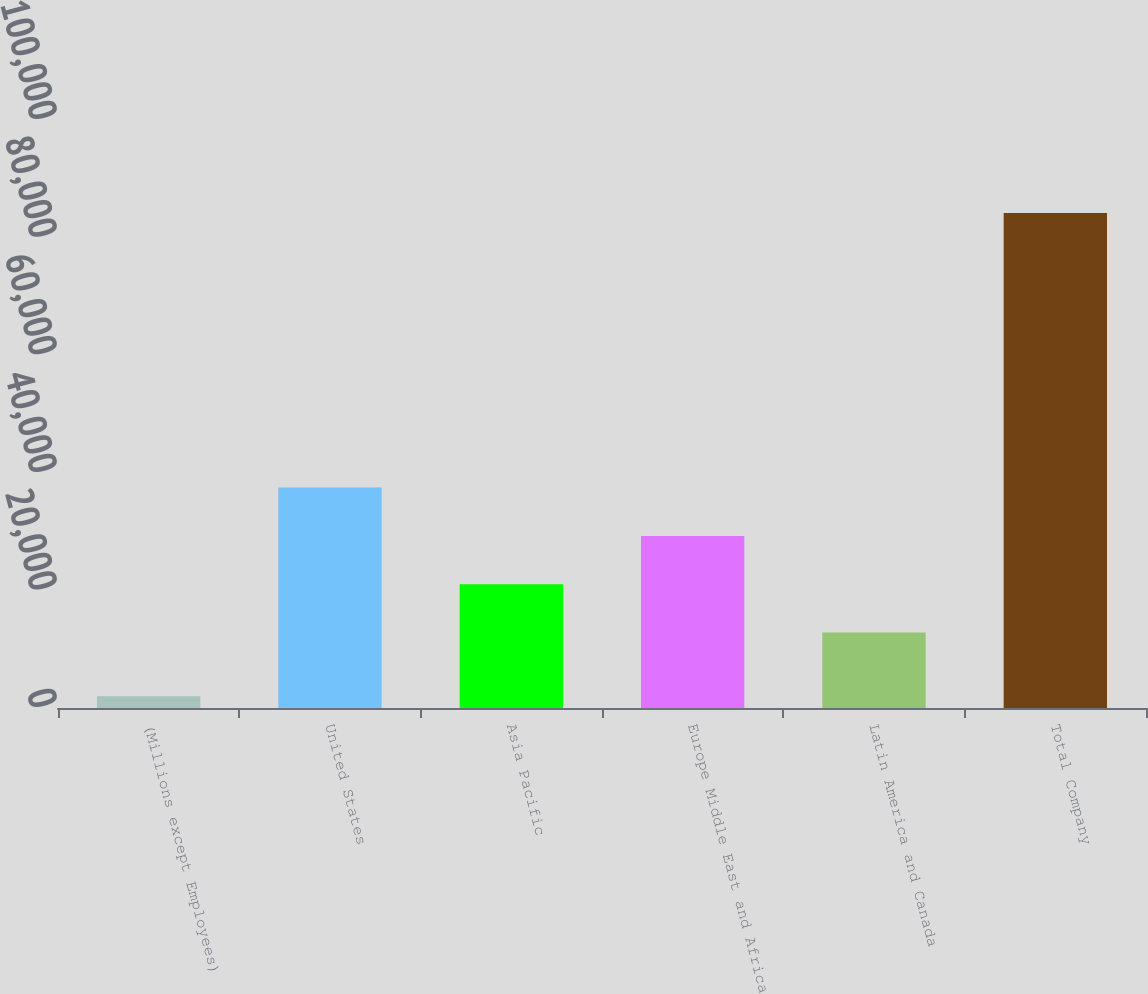<chart> <loc_0><loc_0><loc_500><loc_500><bar_chart><fcel>(Millions except Employees)<fcel>United States<fcel>Asia Pacific<fcel>Europe Middle East and Africa<fcel>Latin America and Canada<fcel>Total Company<nl><fcel>2011<fcel>37480.1<fcel>21042.7<fcel>29261.4<fcel>12824<fcel>84198<nl></chart> 